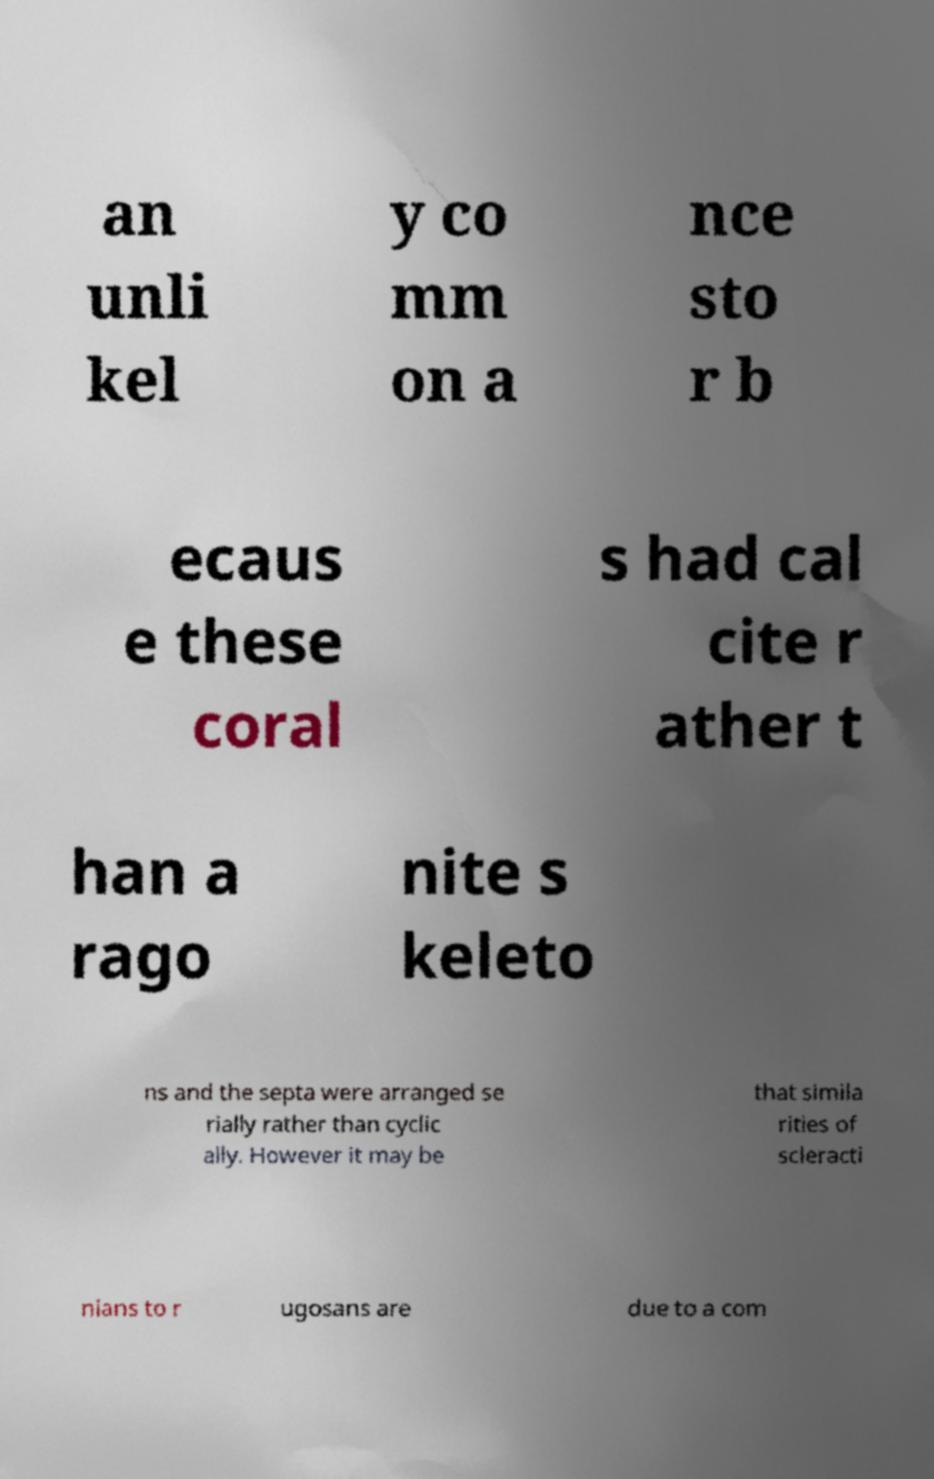For documentation purposes, I need the text within this image transcribed. Could you provide that? an unli kel y co mm on a nce sto r b ecaus e these coral s had cal cite r ather t han a rago nite s keleto ns and the septa were arranged se rially rather than cyclic ally. However it may be that simila rities of scleracti nians to r ugosans are due to a com 